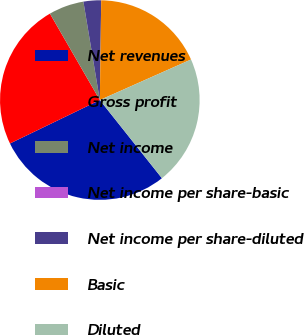Convert chart. <chart><loc_0><loc_0><loc_500><loc_500><pie_chart><fcel>Net revenues<fcel>Gross profit<fcel>Net income<fcel>Net income per share-basic<fcel>Net income per share-diluted<fcel>Basic<fcel>Diluted<nl><fcel>28.52%<fcel>23.83%<fcel>5.7%<fcel>0.0%<fcel>2.85%<fcel>18.12%<fcel>20.97%<nl></chart> 